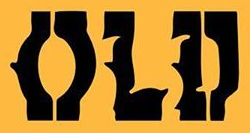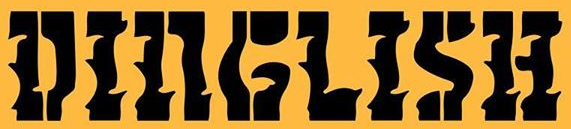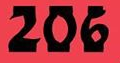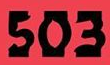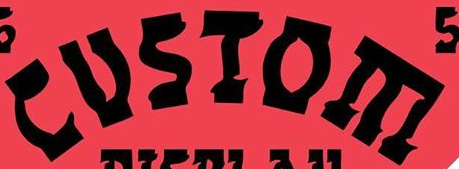What words are shown in these images in order, separated by a semicolon? OLD; DINGLISH; 206; 503; CUSIOE 